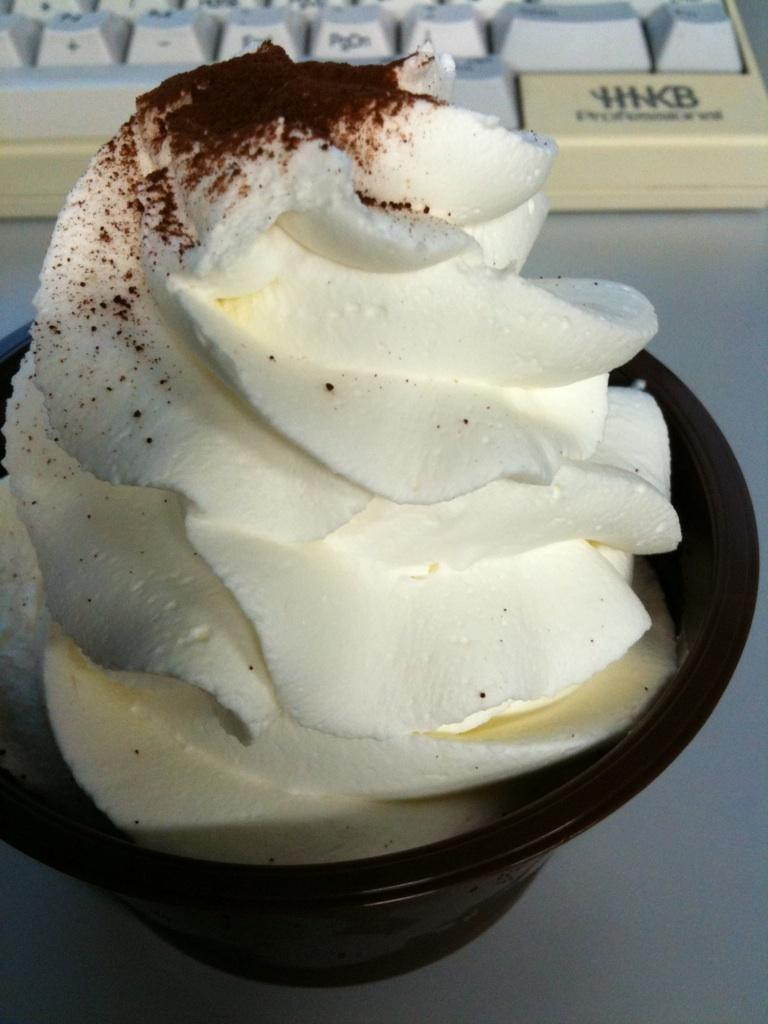What is in the bowl that is visible in the image? There is an ice cream in a bowl in the image. Where is the bowl located in the image? The bowl is on a table in the image. What other object can be seen in the image besides the bowl of ice cream? There is a keyboard visible at the top of the image. What type of plants are growing on the base of the keyboard in the image? There are no plants visible in the image, and the keyboard does not have a base. 